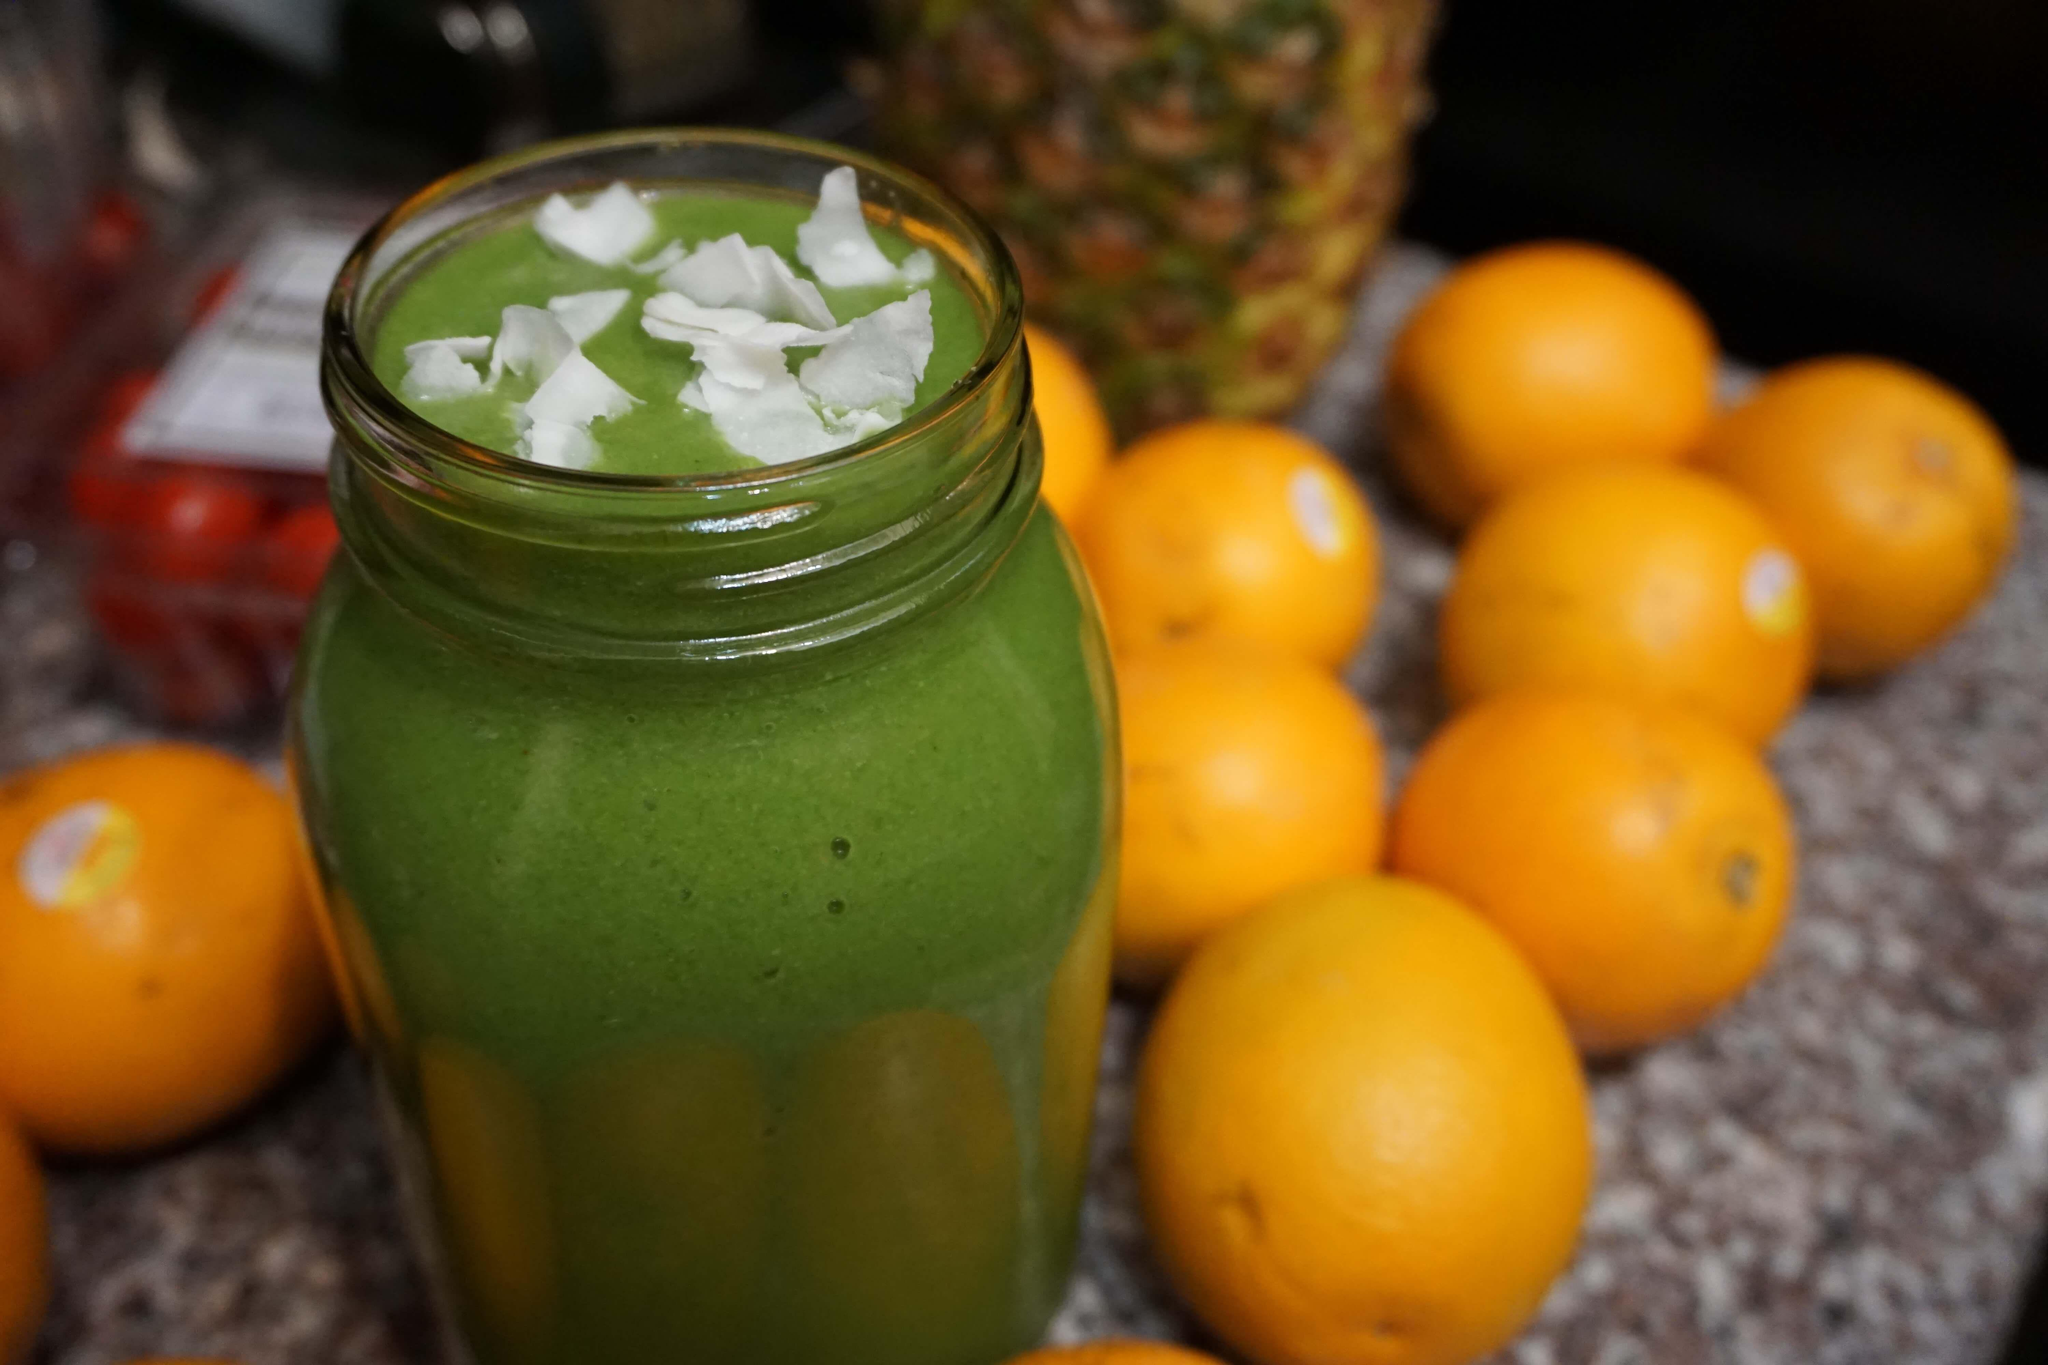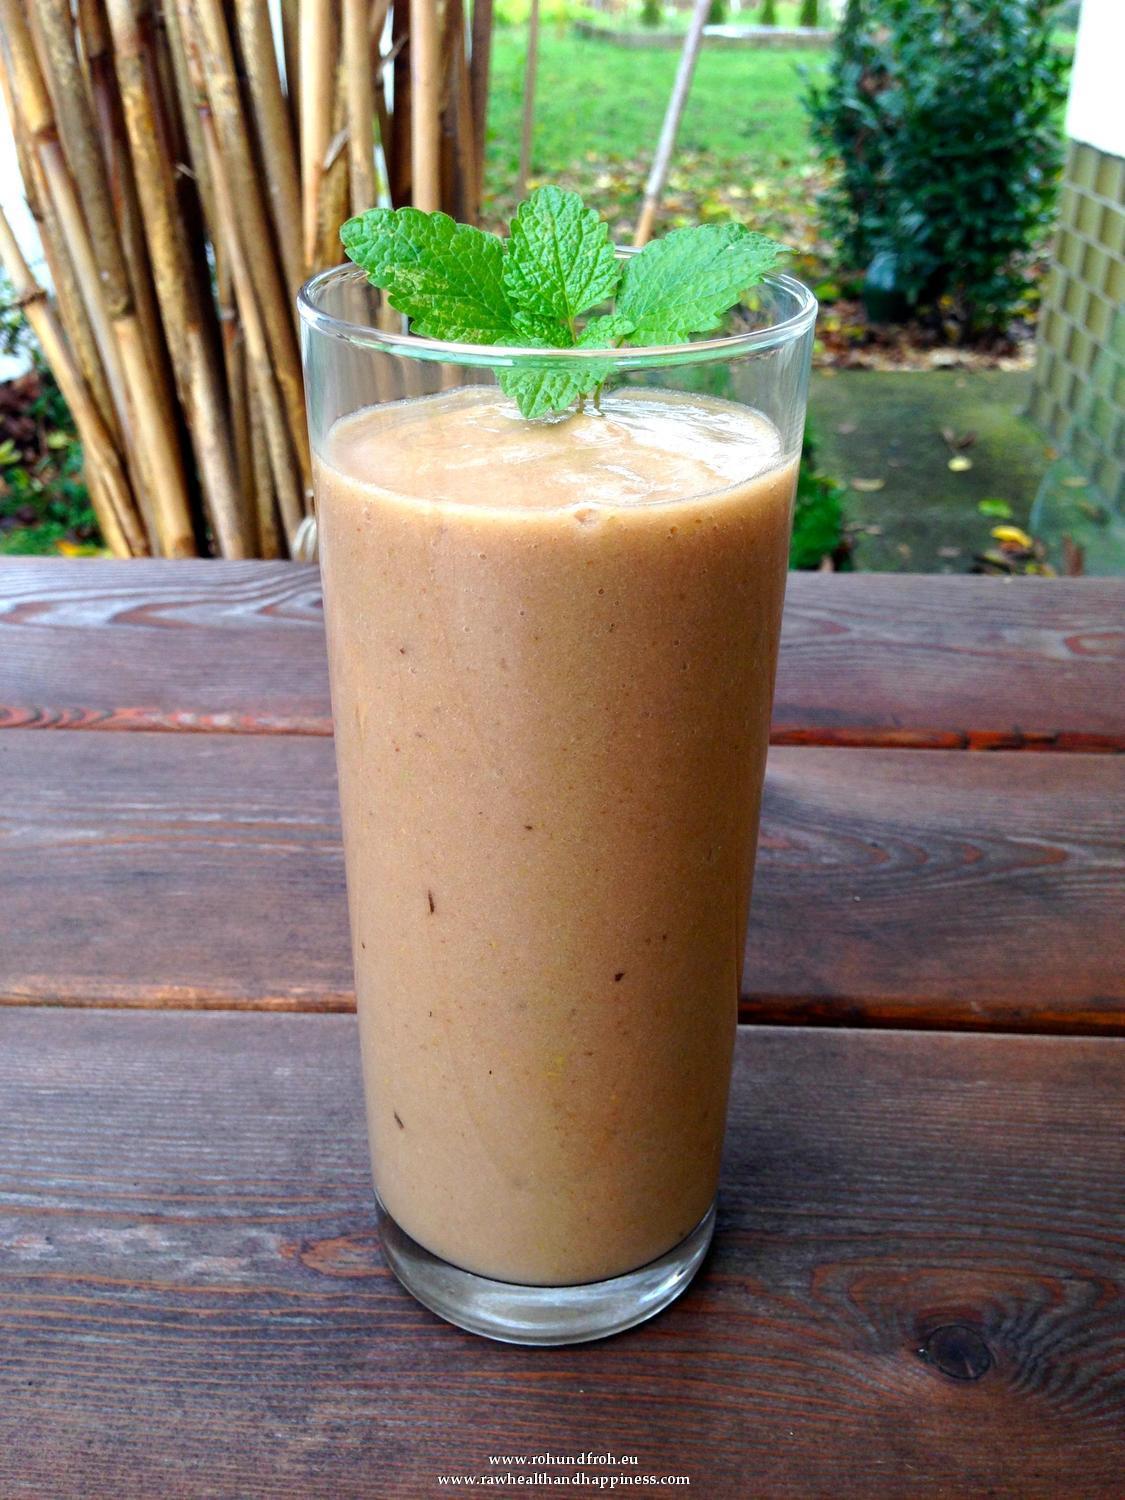The first image is the image on the left, the second image is the image on the right. Evaluate the accuracy of this statement regarding the images: "Each image includes one garnished glass of creamy beverage but no straws, and one of the glasses pictured has a leafy green garnish.". Is it true? Answer yes or no. Yes. The first image is the image on the left, the second image is the image on the right. Analyze the images presented: Is the assertion "There is green juice in one of the images." valid? Answer yes or no. Yes. 